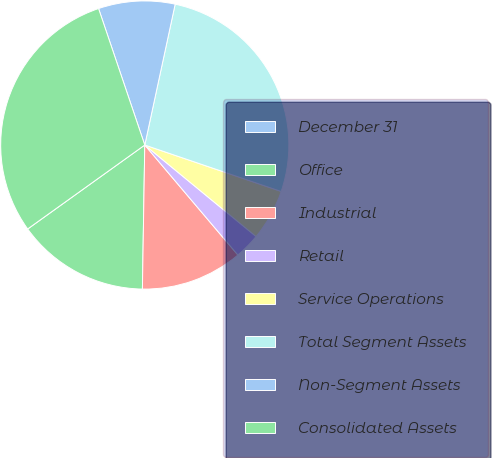Convert chart to OTSL. <chart><loc_0><loc_0><loc_500><loc_500><pie_chart><fcel>December 31<fcel>Office<fcel>Industrial<fcel>Retail<fcel>Service Operations<fcel>Total Segment Assets<fcel>Non-Segment Assets<fcel>Consolidated Assets<nl><fcel>0.01%<fcel>14.83%<fcel>11.44%<fcel>2.87%<fcel>5.73%<fcel>26.84%<fcel>8.58%<fcel>29.7%<nl></chart> 